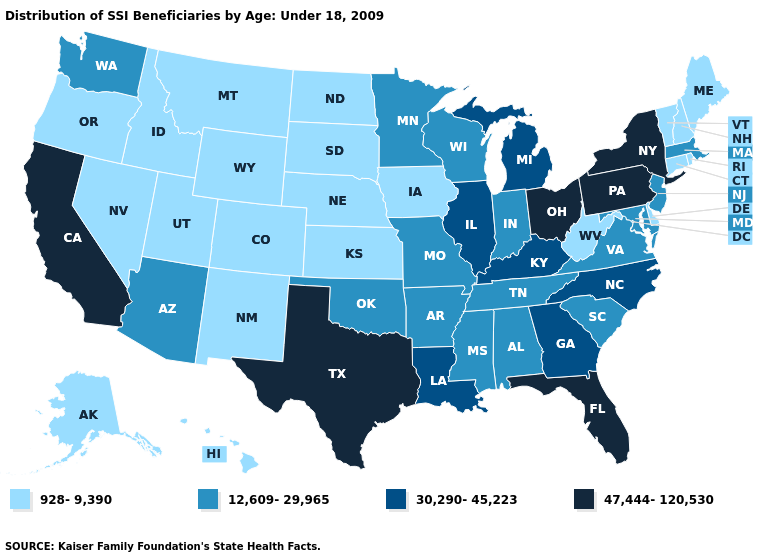What is the value of Arizona?
Short answer required. 12,609-29,965. How many symbols are there in the legend?
Quick response, please. 4. Which states have the lowest value in the West?
Keep it brief. Alaska, Colorado, Hawaii, Idaho, Montana, Nevada, New Mexico, Oregon, Utah, Wyoming. What is the lowest value in the MidWest?
Answer briefly. 928-9,390. Name the states that have a value in the range 12,609-29,965?
Write a very short answer. Alabama, Arizona, Arkansas, Indiana, Maryland, Massachusetts, Minnesota, Mississippi, Missouri, New Jersey, Oklahoma, South Carolina, Tennessee, Virginia, Washington, Wisconsin. What is the highest value in the USA?
Quick response, please. 47,444-120,530. Among the states that border Iowa , does Missouri have the highest value?
Keep it brief. No. Name the states that have a value in the range 12,609-29,965?
Give a very brief answer. Alabama, Arizona, Arkansas, Indiana, Maryland, Massachusetts, Minnesota, Mississippi, Missouri, New Jersey, Oklahoma, South Carolina, Tennessee, Virginia, Washington, Wisconsin. Is the legend a continuous bar?
Quick response, please. No. Is the legend a continuous bar?
Concise answer only. No. What is the lowest value in the West?
Keep it brief. 928-9,390. Name the states that have a value in the range 12,609-29,965?
Write a very short answer. Alabama, Arizona, Arkansas, Indiana, Maryland, Massachusetts, Minnesota, Mississippi, Missouri, New Jersey, Oklahoma, South Carolina, Tennessee, Virginia, Washington, Wisconsin. Name the states that have a value in the range 12,609-29,965?
Concise answer only. Alabama, Arizona, Arkansas, Indiana, Maryland, Massachusetts, Minnesota, Mississippi, Missouri, New Jersey, Oklahoma, South Carolina, Tennessee, Virginia, Washington, Wisconsin. What is the lowest value in the West?
Write a very short answer. 928-9,390. Does the first symbol in the legend represent the smallest category?
Keep it brief. Yes. 